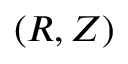<formula> <loc_0><loc_0><loc_500><loc_500>( R , Z )</formula> 